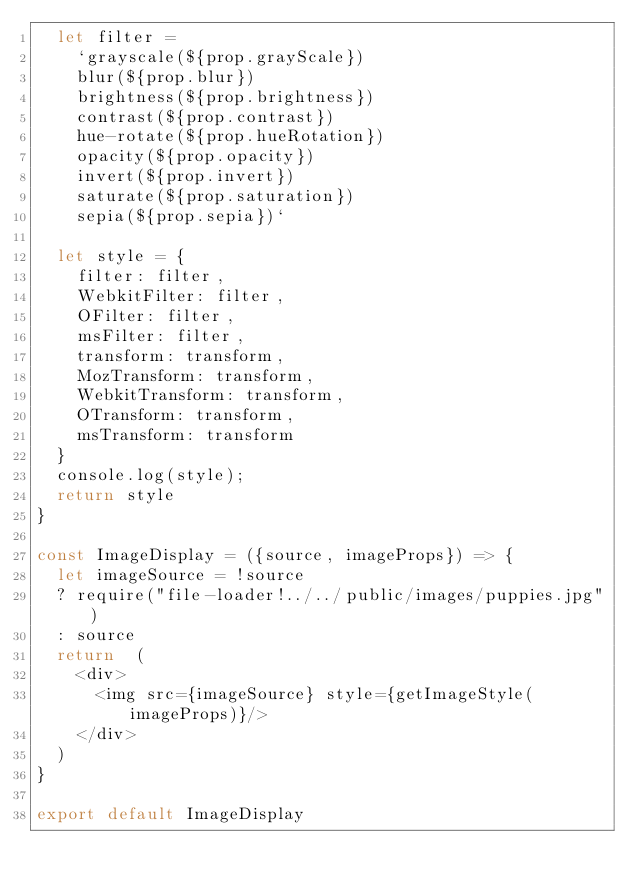<code> <loc_0><loc_0><loc_500><loc_500><_JavaScript_>  let filter =
    `grayscale(${prop.grayScale})
    blur(${prop.blur})
    brightness(${prop.brightness})
    contrast(${prop.contrast})
    hue-rotate(${prop.hueRotation})
    opacity(${prop.opacity})
    invert(${prop.invert})
    saturate(${prop.saturation})
    sepia(${prop.sepia})`

  let style = {
    filter: filter,
    WebkitFilter: filter,
    OFilter: filter,
    msFilter: filter,
    transform: transform,
    MozTransform: transform,
    WebkitTransform: transform,
    OTransform: transform,
    msTransform: transform
  }
  console.log(style);
  return style
}

const ImageDisplay = ({source, imageProps}) => {
  let imageSource = !source
  ? require("file-loader!../../public/images/puppies.jpg")
  : source
  return  (
    <div>
      <img src={imageSource} style={getImageStyle(imageProps)}/>
    </div>
  )
}

export default ImageDisplay
</code> 